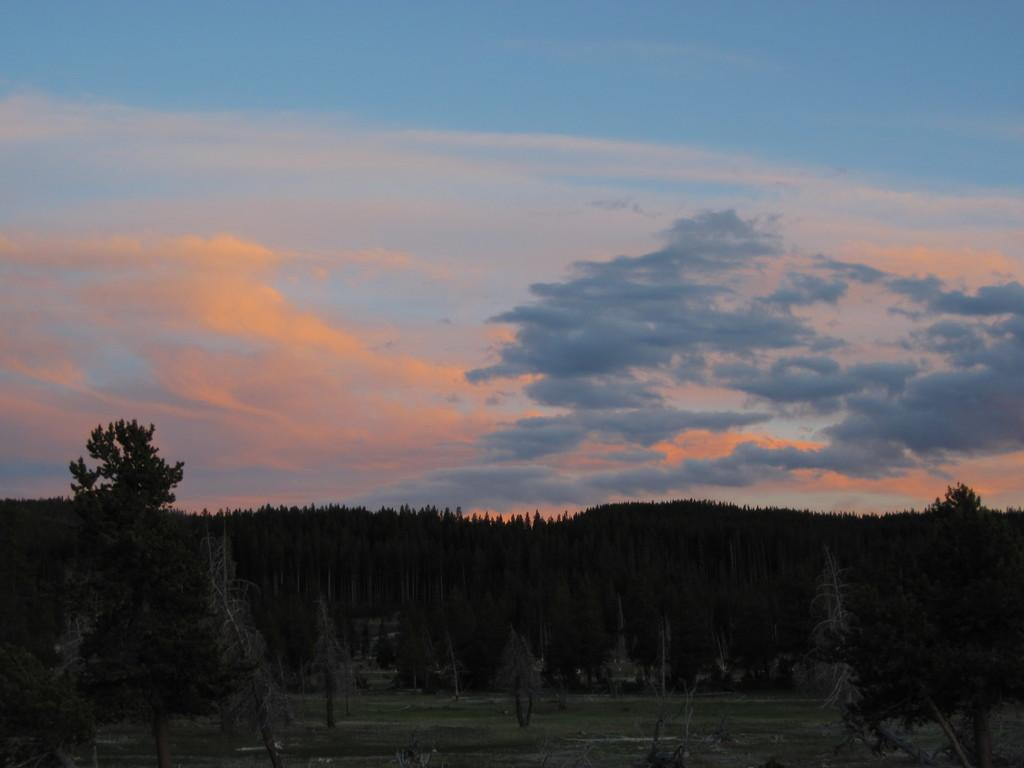What type of vegetation can be seen in the image? There are trees in the image. What is covering the ground in the image? There is grass on the ground in the image. What can be seen in the sky in the background of the image? There are clouds visible in the sky in the background of the image. What type of cherry is being sung in the song in the image? There is no song or cherry present in the image; it features trees, grass, and clouds. 